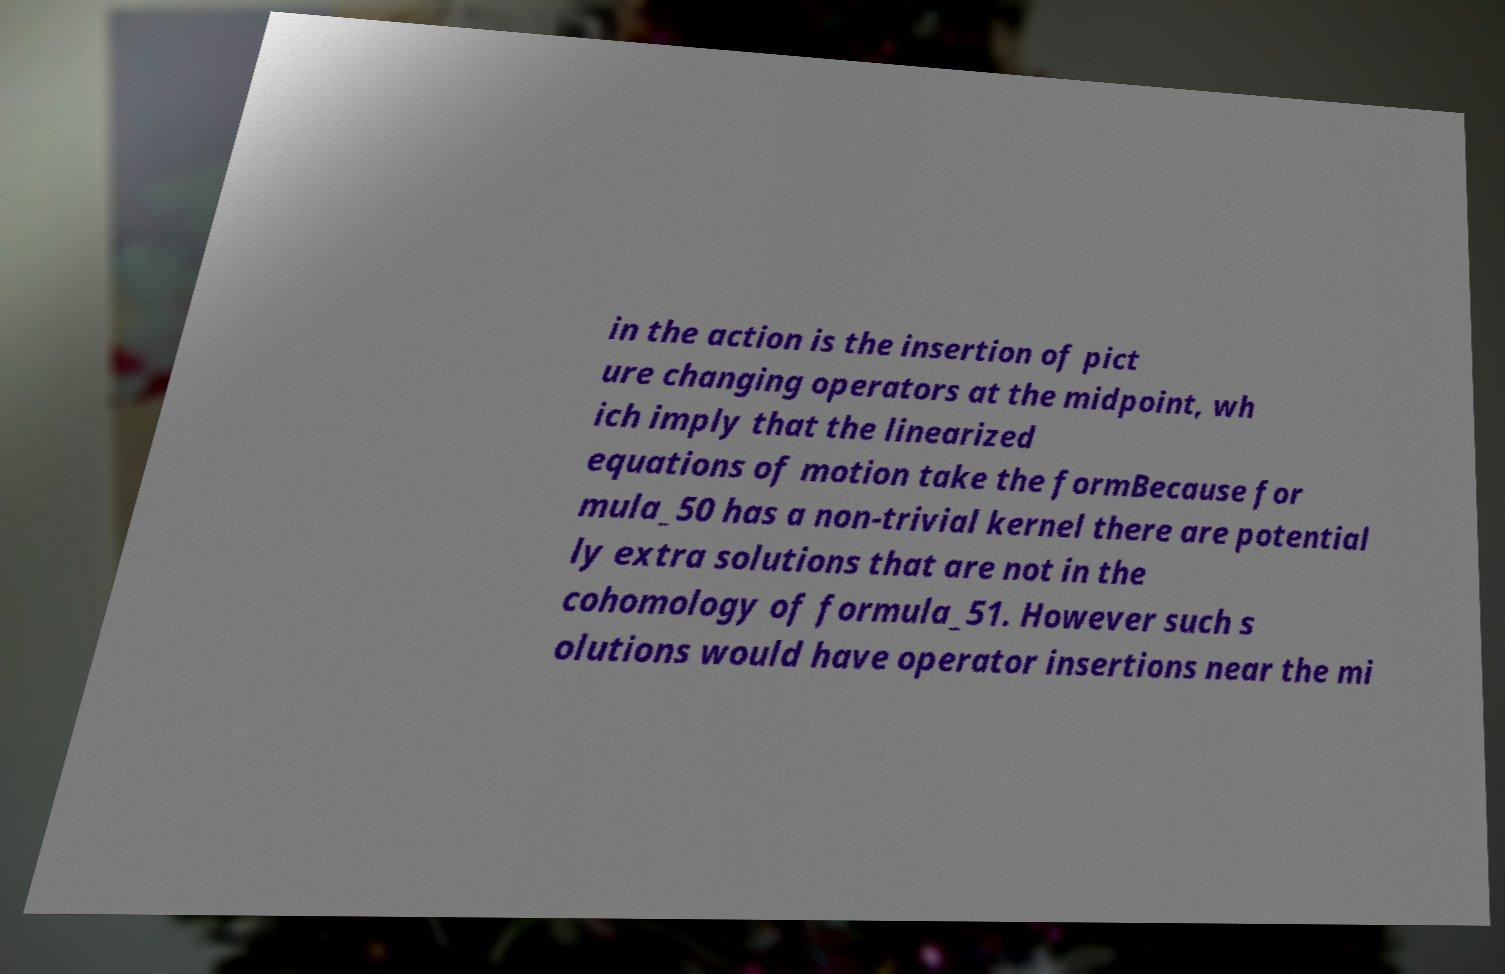Can you read and provide the text displayed in the image?This photo seems to have some interesting text. Can you extract and type it out for me? in the action is the insertion of pict ure changing operators at the midpoint, wh ich imply that the linearized equations of motion take the formBecause for mula_50 has a non-trivial kernel there are potential ly extra solutions that are not in the cohomology of formula_51. However such s olutions would have operator insertions near the mi 